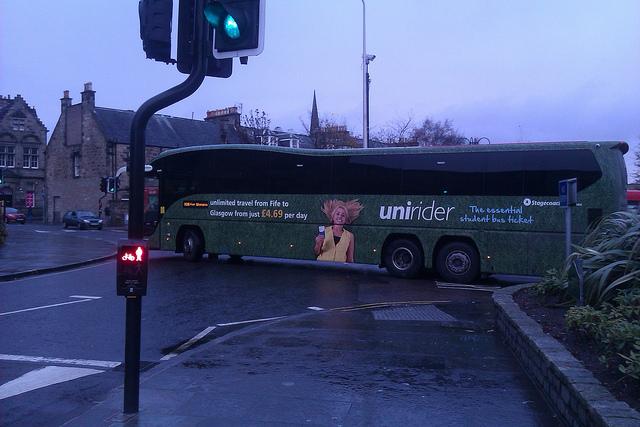What is the name of the company on the bus?
Answer briefly. Unirider. What is the price per day?
Answer briefly. 4.49. Is the girl on the side of the bus lying down?
Give a very brief answer. No. 